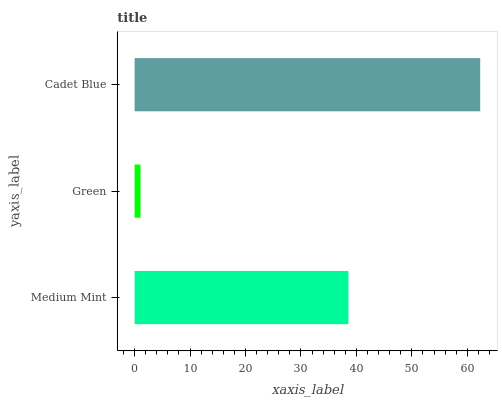Is Green the minimum?
Answer yes or no. Yes. Is Cadet Blue the maximum?
Answer yes or no. Yes. Is Cadet Blue the minimum?
Answer yes or no. No. Is Green the maximum?
Answer yes or no. No. Is Cadet Blue greater than Green?
Answer yes or no. Yes. Is Green less than Cadet Blue?
Answer yes or no. Yes. Is Green greater than Cadet Blue?
Answer yes or no. No. Is Cadet Blue less than Green?
Answer yes or no. No. Is Medium Mint the high median?
Answer yes or no. Yes. Is Medium Mint the low median?
Answer yes or no. Yes. Is Cadet Blue the high median?
Answer yes or no. No. Is Green the low median?
Answer yes or no. No. 